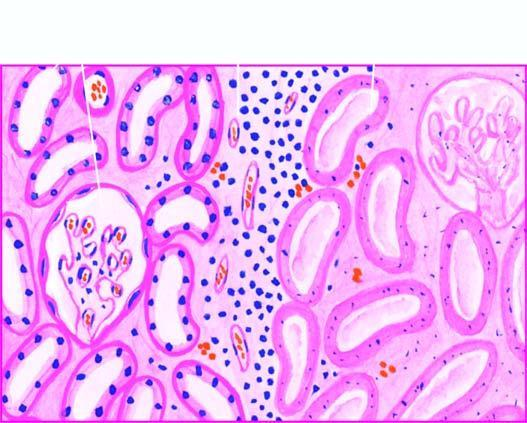where is the affected area?
Answer the question using a single word or phrase. On right 